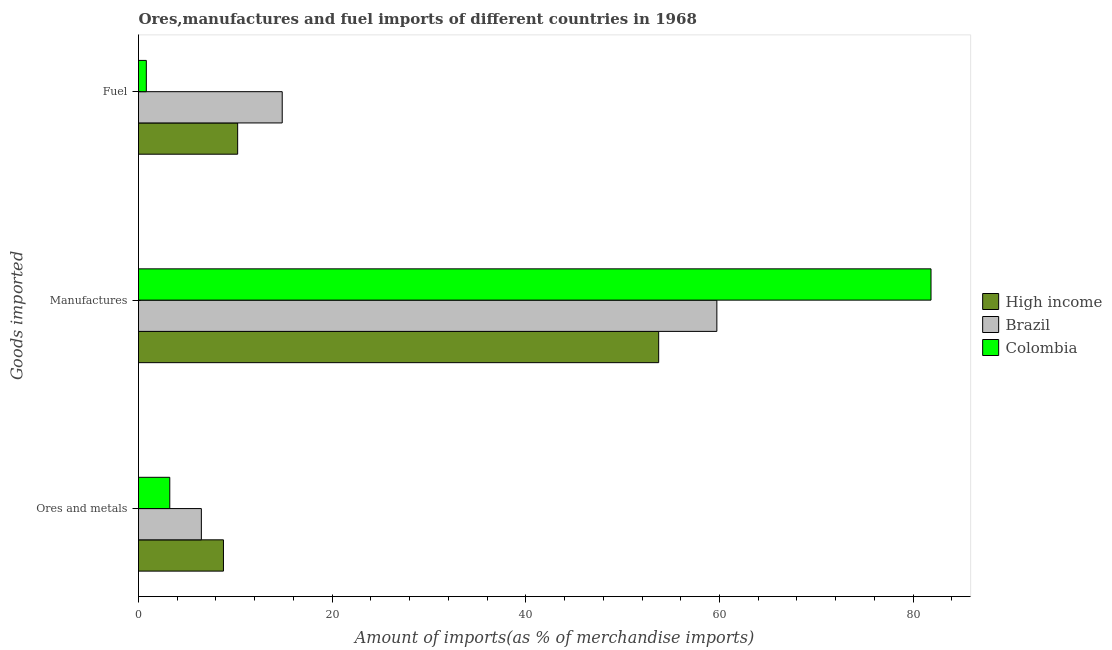How many different coloured bars are there?
Keep it short and to the point. 3. Are the number of bars per tick equal to the number of legend labels?
Your response must be concise. Yes. Are the number of bars on each tick of the Y-axis equal?
Offer a very short reply. Yes. How many bars are there on the 3rd tick from the top?
Keep it short and to the point. 3. What is the label of the 1st group of bars from the top?
Your response must be concise. Fuel. What is the percentage of ores and metals imports in Brazil?
Provide a short and direct response. 6.49. Across all countries, what is the maximum percentage of ores and metals imports?
Ensure brevity in your answer.  8.77. Across all countries, what is the minimum percentage of manufactures imports?
Offer a terse response. 53.72. In which country was the percentage of ores and metals imports maximum?
Your answer should be compact. High income. What is the total percentage of ores and metals imports in the graph?
Your answer should be compact. 18.49. What is the difference between the percentage of fuel imports in Brazil and that in High income?
Offer a terse response. 4.6. What is the difference between the percentage of fuel imports in Brazil and the percentage of ores and metals imports in Colombia?
Make the answer very short. 11.61. What is the average percentage of manufactures imports per country?
Your response must be concise. 65.09. What is the difference between the percentage of fuel imports and percentage of manufactures imports in Brazil?
Ensure brevity in your answer.  -44.88. In how many countries, is the percentage of fuel imports greater than 76 %?
Your answer should be very brief. 0. What is the ratio of the percentage of fuel imports in Colombia to that in High income?
Offer a very short reply. 0.08. Is the difference between the percentage of manufactures imports in High income and Colombia greater than the difference between the percentage of ores and metals imports in High income and Colombia?
Provide a succinct answer. No. What is the difference between the highest and the second highest percentage of ores and metals imports?
Provide a succinct answer. 2.28. What is the difference between the highest and the lowest percentage of manufactures imports?
Keep it short and to the point. 28.13. What does the 3rd bar from the top in Ores and metals represents?
Give a very brief answer. High income. How many bars are there?
Your response must be concise. 9. Are all the bars in the graph horizontal?
Your answer should be compact. Yes. How many countries are there in the graph?
Your answer should be compact. 3. What is the difference between two consecutive major ticks on the X-axis?
Your answer should be very brief. 20. Are the values on the major ticks of X-axis written in scientific E-notation?
Give a very brief answer. No. How many legend labels are there?
Your answer should be very brief. 3. How are the legend labels stacked?
Ensure brevity in your answer.  Vertical. What is the title of the graph?
Provide a short and direct response. Ores,manufactures and fuel imports of different countries in 1968. Does "Jordan" appear as one of the legend labels in the graph?
Provide a short and direct response. No. What is the label or title of the X-axis?
Give a very brief answer. Amount of imports(as % of merchandise imports). What is the label or title of the Y-axis?
Provide a short and direct response. Goods imported. What is the Amount of imports(as % of merchandise imports) in High income in Ores and metals?
Make the answer very short. 8.77. What is the Amount of imports(as % of merchandise imports) of Brazil in Ores and metals?
Offer a very short reply. 6.49. What is the Amount of imports(as % of merchandise imports) of Colombia in Ores and metals?
Make the answer very short. 3.23. What is the Amount of imports(as % of merchandise imports) of High income in Manufactures?
Keep it short and to the point. 53.72. What is the Amount of imports(as % of merchandise imports) of Brazil in Manufactures?
Provide a succinct answer. 59.73. What is the Amount of imports(as % of merchandise imports) of Colombia in Manufactures?
Give a very brief answer. 81.84. What is the Amount of imports(as % of merchandise imports) in High income in Fuel?
Give a very brief answer. 10.24. What is the Amount of imports(as % of merchandise imports) in Brazil in Fuel?
Provide a short and direct response. 14.84. What is the Amount of imports(as % of merchandise imports) of Colombia in Fuel?
Ensure brevity in your answer.  0.81. Across all Goods imported, what is the maximum Amount of imports(as % of merchandise imports) of High income?
Provide a short and direct response. 53.72. Across all Goods imported, what is the maximum Amount of imports(as % of merchandise imports) of Brazil?
Your response must be concise. 59.73. Across all Goods imported, what is the maximum Amount of imports(as % of merchandise imports) of Colombia?
Your answer should be compact. 81.84. Across all Goods imported, what is the minimum Amount of imports(as % of merchandise imports) in High income?
Provide a short and direct response. 8.77. Across all Goods imported, what is the minimum Amount of imports(as % of merchandise imports) of Brazil?
Your response must be concise. 6.49. Across all Goods imported, what is the minimum Amount of imports(as % of merchandise imports) of Colombia?
Make the answer very short. 0.81. What is the total Amount of imports(as % of merchandise imports) of High income in the graph?
Your answer should be very brief. 72.73. What is the total Amount of imports(as % of merchandise imports) in Brazil in the graph?
Offer a very short reply. 81.06. What is the total Amount of imports(as % of merchandise imports) of Colombia in the graph?
Keep it short and to the point. 85.88. What is the difference between the Amount of imports(as % of merchandise imports) in High income in Ores and metals and that in Manufactures?
Make the answer very short. -44.95. What is the difference between the Amount of imports(as % of merchandise imports) of Brazil in Ores and metals and that in Manufactures?
Your answer should be compact. -53.23. What is the difference between the Amount of imports(as % of merchandise imports) of Colombia in Ores and metals and that in Manufactures?
Keep it short and to the point. -78.61. What is the difference between the Amount of imports(as % of merchandise imports) in High income in Ores and metals and that in Fuel?
Your response must be concise. -1.47. What is the difference between the Amount of imports(as % of merchandise imports) of Brazil in Ores and metals and that in Fuel?
Ensure brevity in your answer.  -8.35. What is the difference between the Amount of imports(as % of merchandise imports) of Colombia in Ores and metals and that in Fuel?
Give a very brief answer. 2.42. What is the difference between the Amount of imports(as % of merchandise imports) in High income in Manufactures and that in Fuel?
Offer a very short reply. 43.48. What is the difference between the Amount of imports(as % of merchandise imports) of Brazil in Manufactures and that in Fuel?
Make the answer very short. 44.88. What is the difference between the Amount of imports(as % of merchandise imports) in Colombia in Manufactures and that in Fuel?
Ensure brevity in your answer.  81.04. What is the difference between the Amount of imports(as % of merchandise imports) in High income in Ores and metals and the Amount of imports(as % of merchandise imports) in Brazil in Manufactures?
Ensure brevity in your answer.  -50.95. What is the difference between the Amount of imports(as % of merchandise imports) in High income in Ores and metals and the Amount of imports(as % of merchandise imports) in Colombia in Manufactures?
Keep it short and to the point. -73.07. What is the difference between the Amount of imports(as % of merchandise imports) of Brazil in Ores and metals and the Amount of imports(as % of merchandise imports) of Colombia in Manufactures?
Your response must be concise. -75.35. What is the difference between the Amount of imports(as % of merchandise imports) in High income in Ores and metals and the Amount of imports(as % of merchandise imports) in Brazil in Fuel?
Ensure brevity in your answer.  -6.07. What is the difference between the Amount of imports(as % of merchandise imports) in High income in Ores and metals and the Amount of imports(as % of merchandise imports) in Colombia in Fuel?
Your response must be concise. 7.96. What is the difference between the Amount of imports(as % of merchandise imports) in Brazil in Ores and metals and the Amount of imports(as % of merchandise imports) in Colombia in Fuel?
Your answer should be very brief. 5.68. What is the difference between the Amount of imports(as % of merchandise imports) of High income in Manufactures and the Amount of imports(as % of merchandise imports) of Brazil in Fuel?
Offer a terse response. 38.88. What is the difference between the Amount of imports(as % of merchandise imports) in High income in Manufactures and the Amount of imports(as % of merchandise imports) in Colombia in Fuel?
Your response must be concise. 52.91. What is the difference between the Amount of imports(as % of merchandise imports) in Brazil in Manufactures and the Amount of imports(as % of merchandise imports) in Colombia in Fuel?
Give a very brief answer. 58.92. What is the average Amount of imports(as % of merchandise imports) of High income per Goods imported?
Give a very brief answer. 24.24. What is the average Amount of imports(as % of merchandise imports) of Brazil per Goods imported?
Keep it short and to the point. 27.02. What is the average Amount of imports(as % of merchandise imports) in Colombia per Goods imported?
Keep it short and to the point. 28.63. What is the difference between the Amount of imports(as % of merchandise imports) of High income and Amount of imports(as % of merchandise imports) of Brazil in Ores and metals?
Your response must be concise. 2.28. What is the difference between the Amount of imports(as % of merchandise imports) in High income and Amount of imports(as % of merchandise imports) in Colombia in Ores and metals?
Your answer should be very brief. 5.54. What is the difference between the Amount of imports(as % of merchandise imports) of Brazil and Amount of imports(as % of merchandise imports) of Colombia in Ores and metals?
Provide a succinct answer. 3.26. What is the difference between the Amount of imports(as % of merchandise imports) in High income and Amount of imports(as % of merchandise imports) in Brazil in Manufactures?
Provide a succinct answer. -6.01. What is the difference between the Amount of imports(as % of merchandise imports) in High income and Amount of imports(as % of merchandise imports) in Colombia in Manufactures?
Your answer should be compact. -28.13. What is the difference between the Amount of imports(as % of merchandise imports) in Brazil and Amount of imports(as % of merchandise imports) in Colombia in Manufactures?
Your answer should be very brief. -22.12. What is the difference between the Amount of imports(as % of merchandise imports) in High income and Amount of imports(as % of merchandise imports) in Brazil in Fuel?
Make the answer very short. -4.6. What is the difference between the Amount of imports(as % of merchandise imports) in High income and Amount of imports(as % of merchandise imports) in Colombia in Fuel?
Provide a succinct answer. 9.43. What is the difference between the Amount of imports(as % of merchandise imports) of Brazil and Amount of imports(as % of merchandise imports) of Colombia in Fuel?
Offer a very short reply. 14.03. What is the ratio of the Amount of imports(as % of merchandise imports) of High income in Ores and metals to that in Manufactures?
Make the answer very short. 0.16. What is the ratio of the Amount of imports(as % of merchandise imports) in Brazil in Ores and metals to that in Manufactures?
Your response must be concise. 0.11. What is the ratio of the Amount of imports(as % of merchandise imports) in Colombia in Ores and metals to that in Manufactures?
Your answer should be compact. 0.04. What is the ratio of the Amount of imports(as % of merchandise imports) of High income in Ores and metals to that in Fuel?
Provide a succinct answer. 0.86. What is the ratio of the Amount of imports(as % of merchandise imports) of Brazil in Ores and metals to that in Fuel?
Your answer should be compact. 0.44. What is the ratio of the Amount of imports(as % of merchandise imports) in Colombia in Ores and metals to that in Fuel?
Your answer should be compact. 4. What is the ratio of the Amount of imports(as % of merchandise imports) in High income in Manufactures to that in Fuel?
Ensure brevity in your answer.  5.25. What is the ratio of the Amount of imports(as % of merchandise imports) of Brazil in Manufactures to that in Fuel?
Provide a short and direct response. 4.02. What is the ratio of the Amount of imports(as % of merchandise imports) of Colombia in Manufactures to that in Fuel?
Your answer should be compact. 101.42. What is the difference between the highest and the second highest Amount of imports(as % of merchandise imports) in High income?
Your answer should be very brief. 43.48. What is the difference between the highest and the second highest Amount of imports(as % of merchandise imports) in Brazil?
Your response must be concise. 44.88. What is the difference between the highest and the second highest Amount of imports(as % of merchandise imports) in Colombia?
Offer a terse response. 78.61. What is the difference between the highest and the lowest Amount of imports(as % of merchandise imports) of High income?
Provide a succinct answer. 44.95. What is the difference between the highest and the lowest Amount of imports(as % of merchandise imports) of Brazil?
Your answer should be compact. 53.23. What is the difference between the highest and the lowest Amount of imports(as % of merchandise imports) of Colombia?
Give a very brief answer. 81.04. 